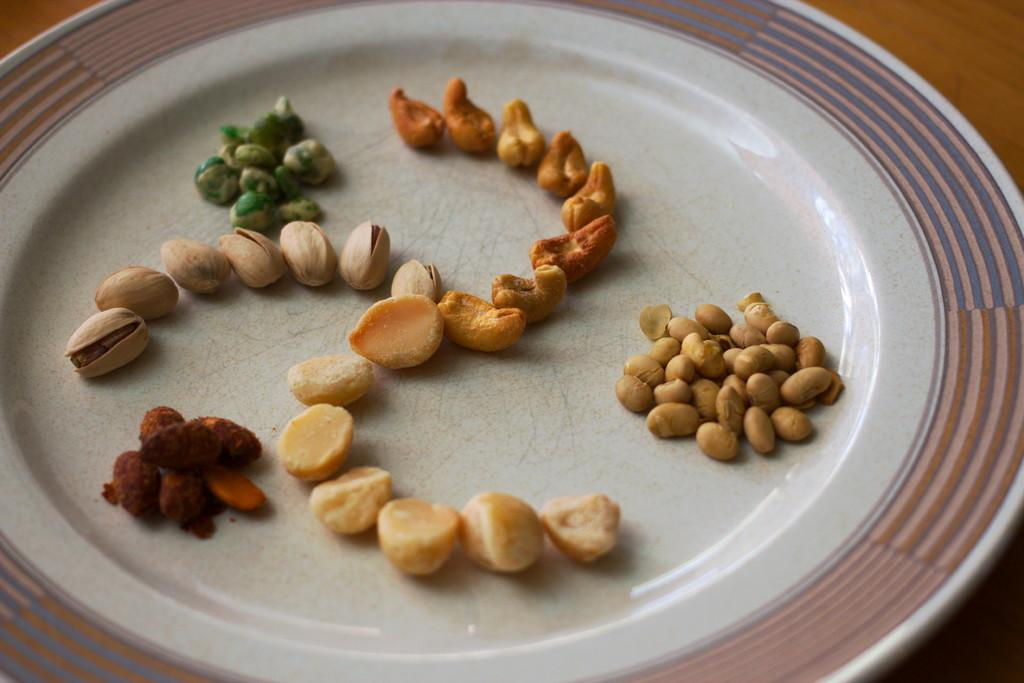What type of food is on the plate in the image? There are dry fruits on a plate in the image. What is the plate placed on? The plate is placed on an object, but the specific object is not mentioned in the facts. What type of bird is flying over the dry fruits in the image? There is no bird present in the image; it only features a plate of dry fruits. 